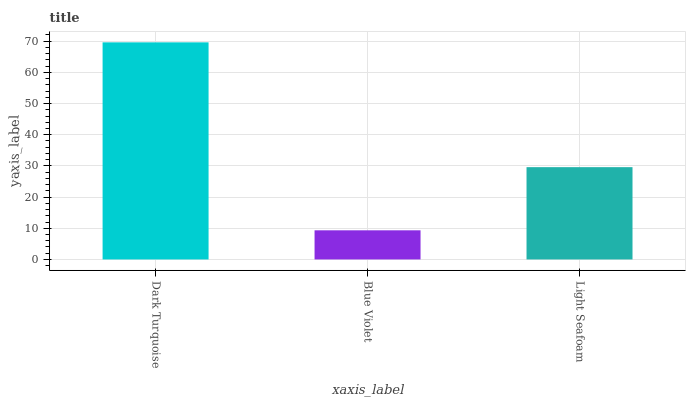Is Blue Violet the minimum?
Answer yes or no. Yes. Is Dark Turquoise the maximum?
Answer yes or no. Yes. Is Light Seafoam the minimum?
Answer yes or no. No. Is Light Seafoam the maximum?
Answer yes or no. No. Is Light Seafoam greater than Blue Violet?
Answer yes or no. Yes. Is Blue Violet less than Light Seafoam?
Answer yes or no. Yes. Is Blue Violet greater than Light Seafoam?
Answer yes or no. No. Is Light Seafoam less than Blue Violet?
Answer yes or no. No. Is Light Seafoam the high median?
Answer yes or no. Yes. Is Light Seafoam the low median?
Answer yes or no. Yes. Is Dark Turquoise the high median?
Answer yes or no. No. Is Blue Violet the low median?
Answer yes or no. No. 